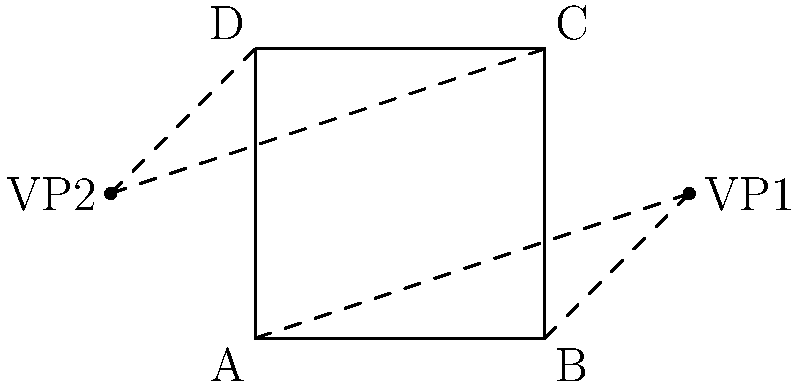In the given perspective drawing of a square, two vanishing points (VP1 and VP2) are used. What type of perspective is being employed, and how does it contribute to creating depth and realism in your artwork? To answer this question, let's analyze the perspective drawing step-by-step:

1. Observe the square ABCD in the diagram.
2. Notice that there are two vanishing points: VP1 and VP2.
3. The lines AD and BC converge towards VP2 on the left.
4. The lines AB and DC converge towards VP1 on the right.
5. Both vanishing points are located on the same horizontal line (the horizon line).

This setup indicates a two-point perspective drawing. Two-point perspective is characterized by:

a) Two vanishing points on the horizon line.
b) Vertical lines remain parallel and perpendicular to the ground.
c) All other lines converge to one of the two vanishing points.

Two-point perspective contributes to creating depth and realism in artwork by:

1. Providing a more natural and less distorted view compared to one-point perspective.
2. Allowing for the representation of objects at angles, which is common in real-life scenes.
3. Creating a sense of space and volume, making objects appear three-dimensional.
4. Enhancing the illusion of depth by showing how parallel lines converge in the distance.
5. Offering flexibility in composition, as the artist can adjust the position of vanishing points to create different effects.

As a contemporary painter, utilizing two-point perspective can help you create visually stunning and thought-provoking artworks by:

- Accurately representing architectural elements or urban landscapes.
- Experimenting with unconventional viewpoints to challenge viewers' perceptions.
- Combining realistic perspective with abstract elements for contrast and visual interest.
- Creating immersive environments that draw the viewer into the artwork's space.
Answer: Two-point perspective; creates depth and realism through accurate spatial representation and converging lines. 